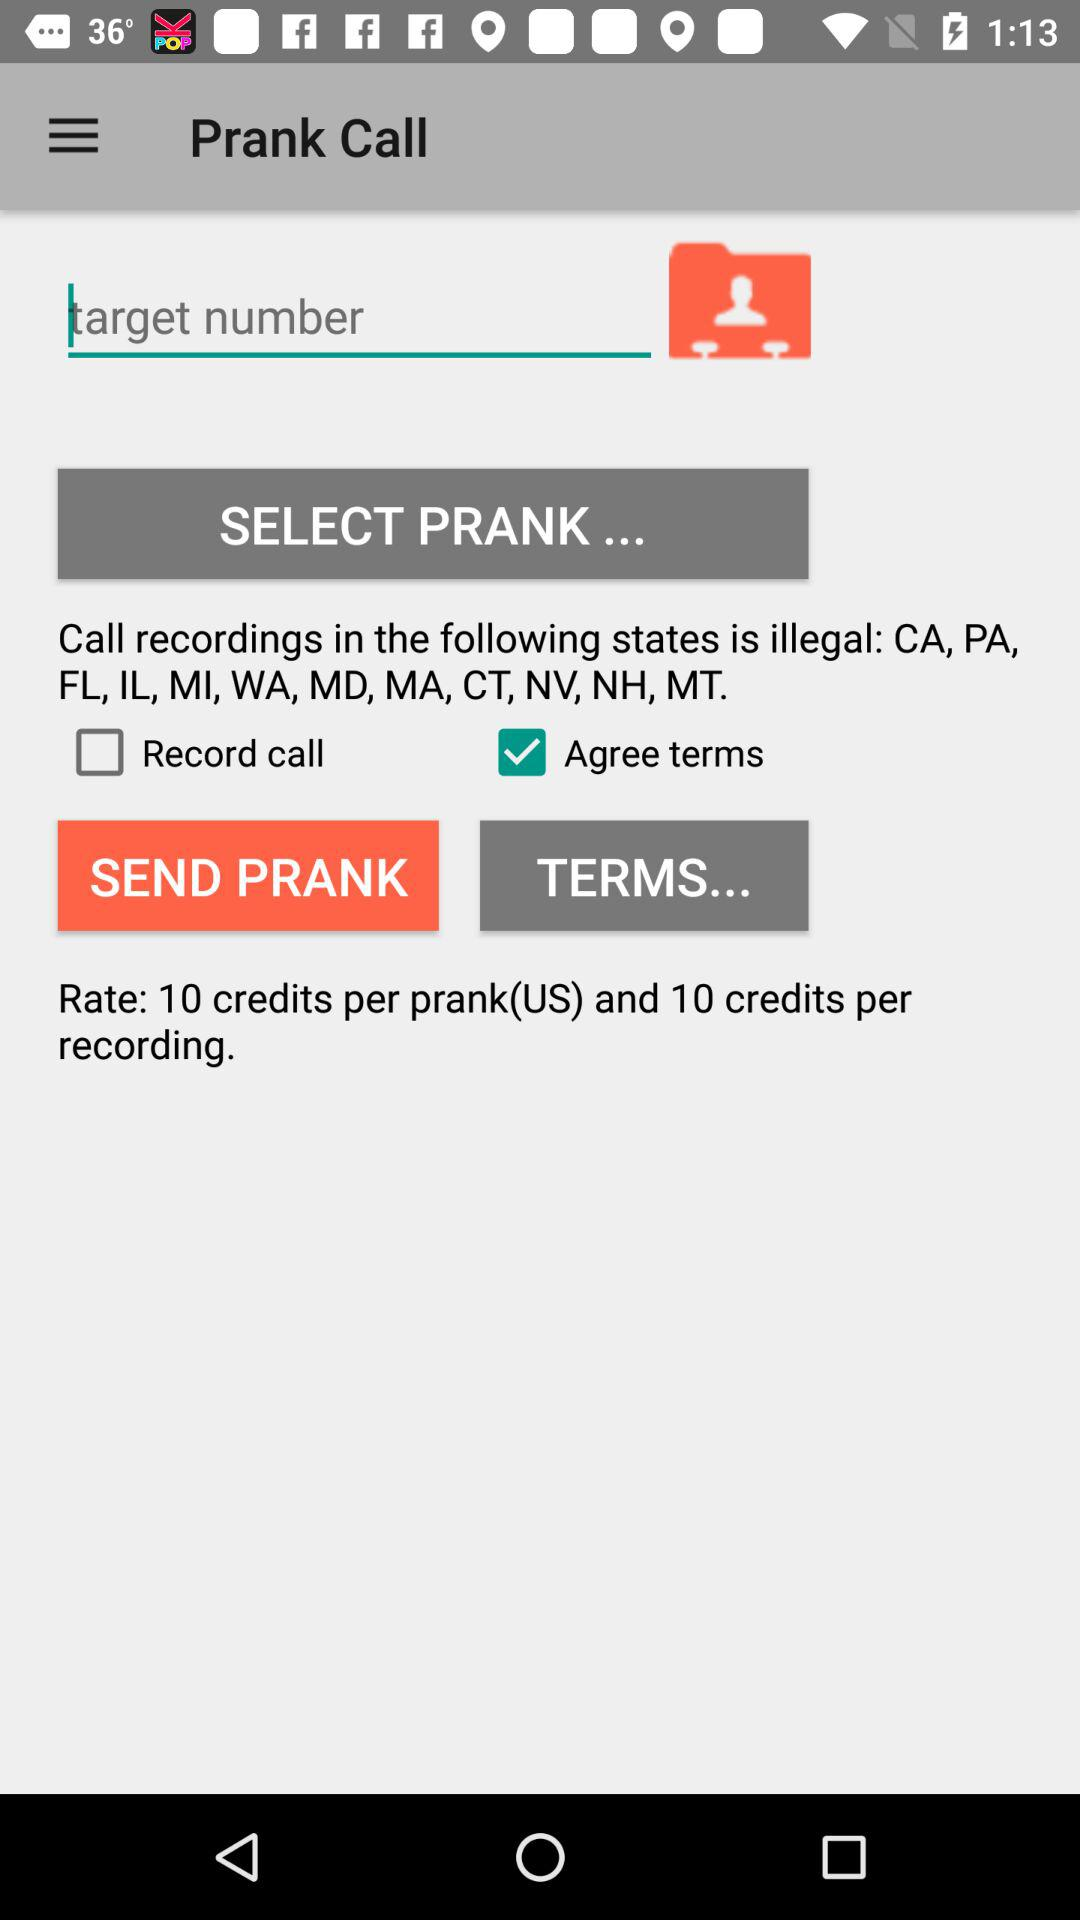Which option is selected? The selected option is "Agree Terms". 